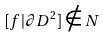Convert formula to latex. <formula><loc_0><loc_0><loc_500><loc_500>[ f | \partial D ^ { 2 } ] \notin N</formula> 